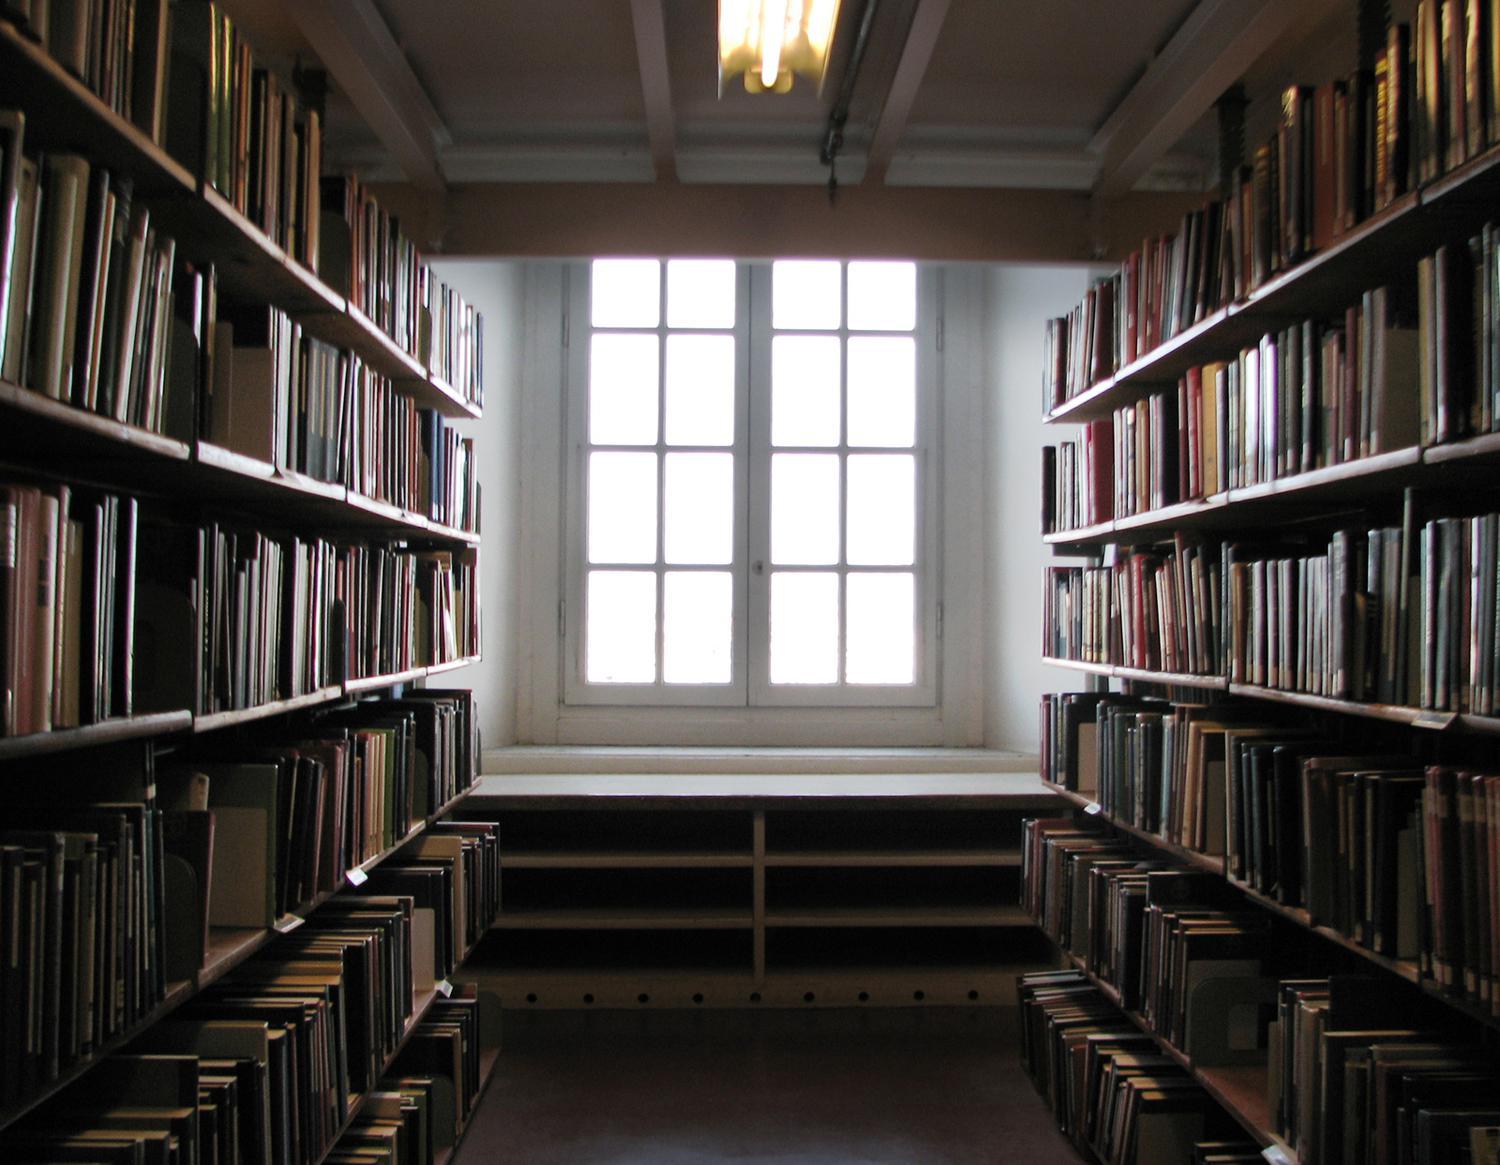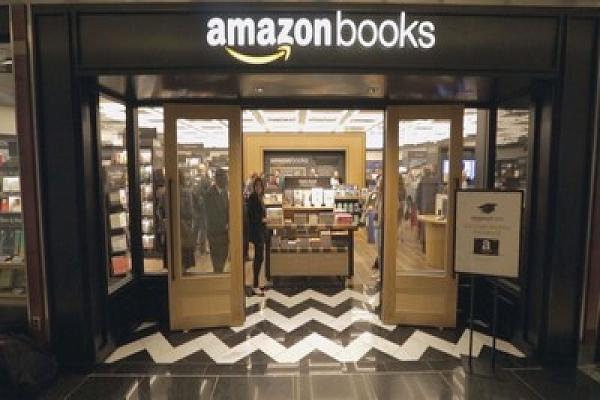The first image is the image on the left, the second image is the image on the right. Considering the images on both sides, is "An interior features bookshelves under at least one arch shape at the back, and upholstered furniture in front." valid? Answer yes or no. No. The first image is the image on the left, the second image is the image on the right. Given the left and right images, does the statement "In at least one image there at least two bookshelves with one window in between them." hold true? Answer yes or no. Yes. 